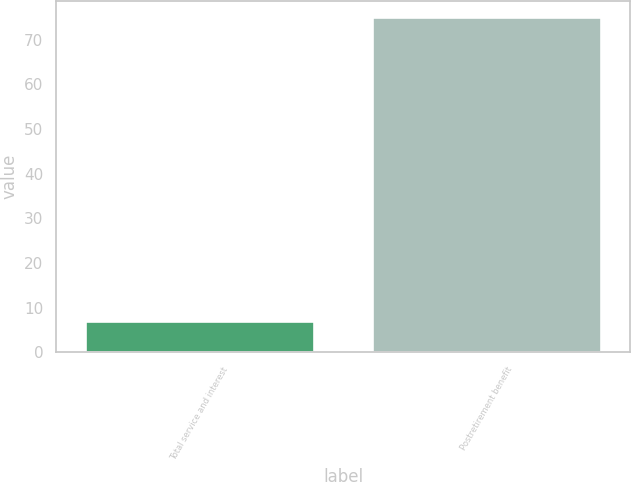Convert chart. <chart><loc_0><loc_0><loc_500><loc_500><bar_chart><fcel>Total service and interest<fcel>Postretirement benefit<nl><fcel>7<fcel>75<nl></chart> 